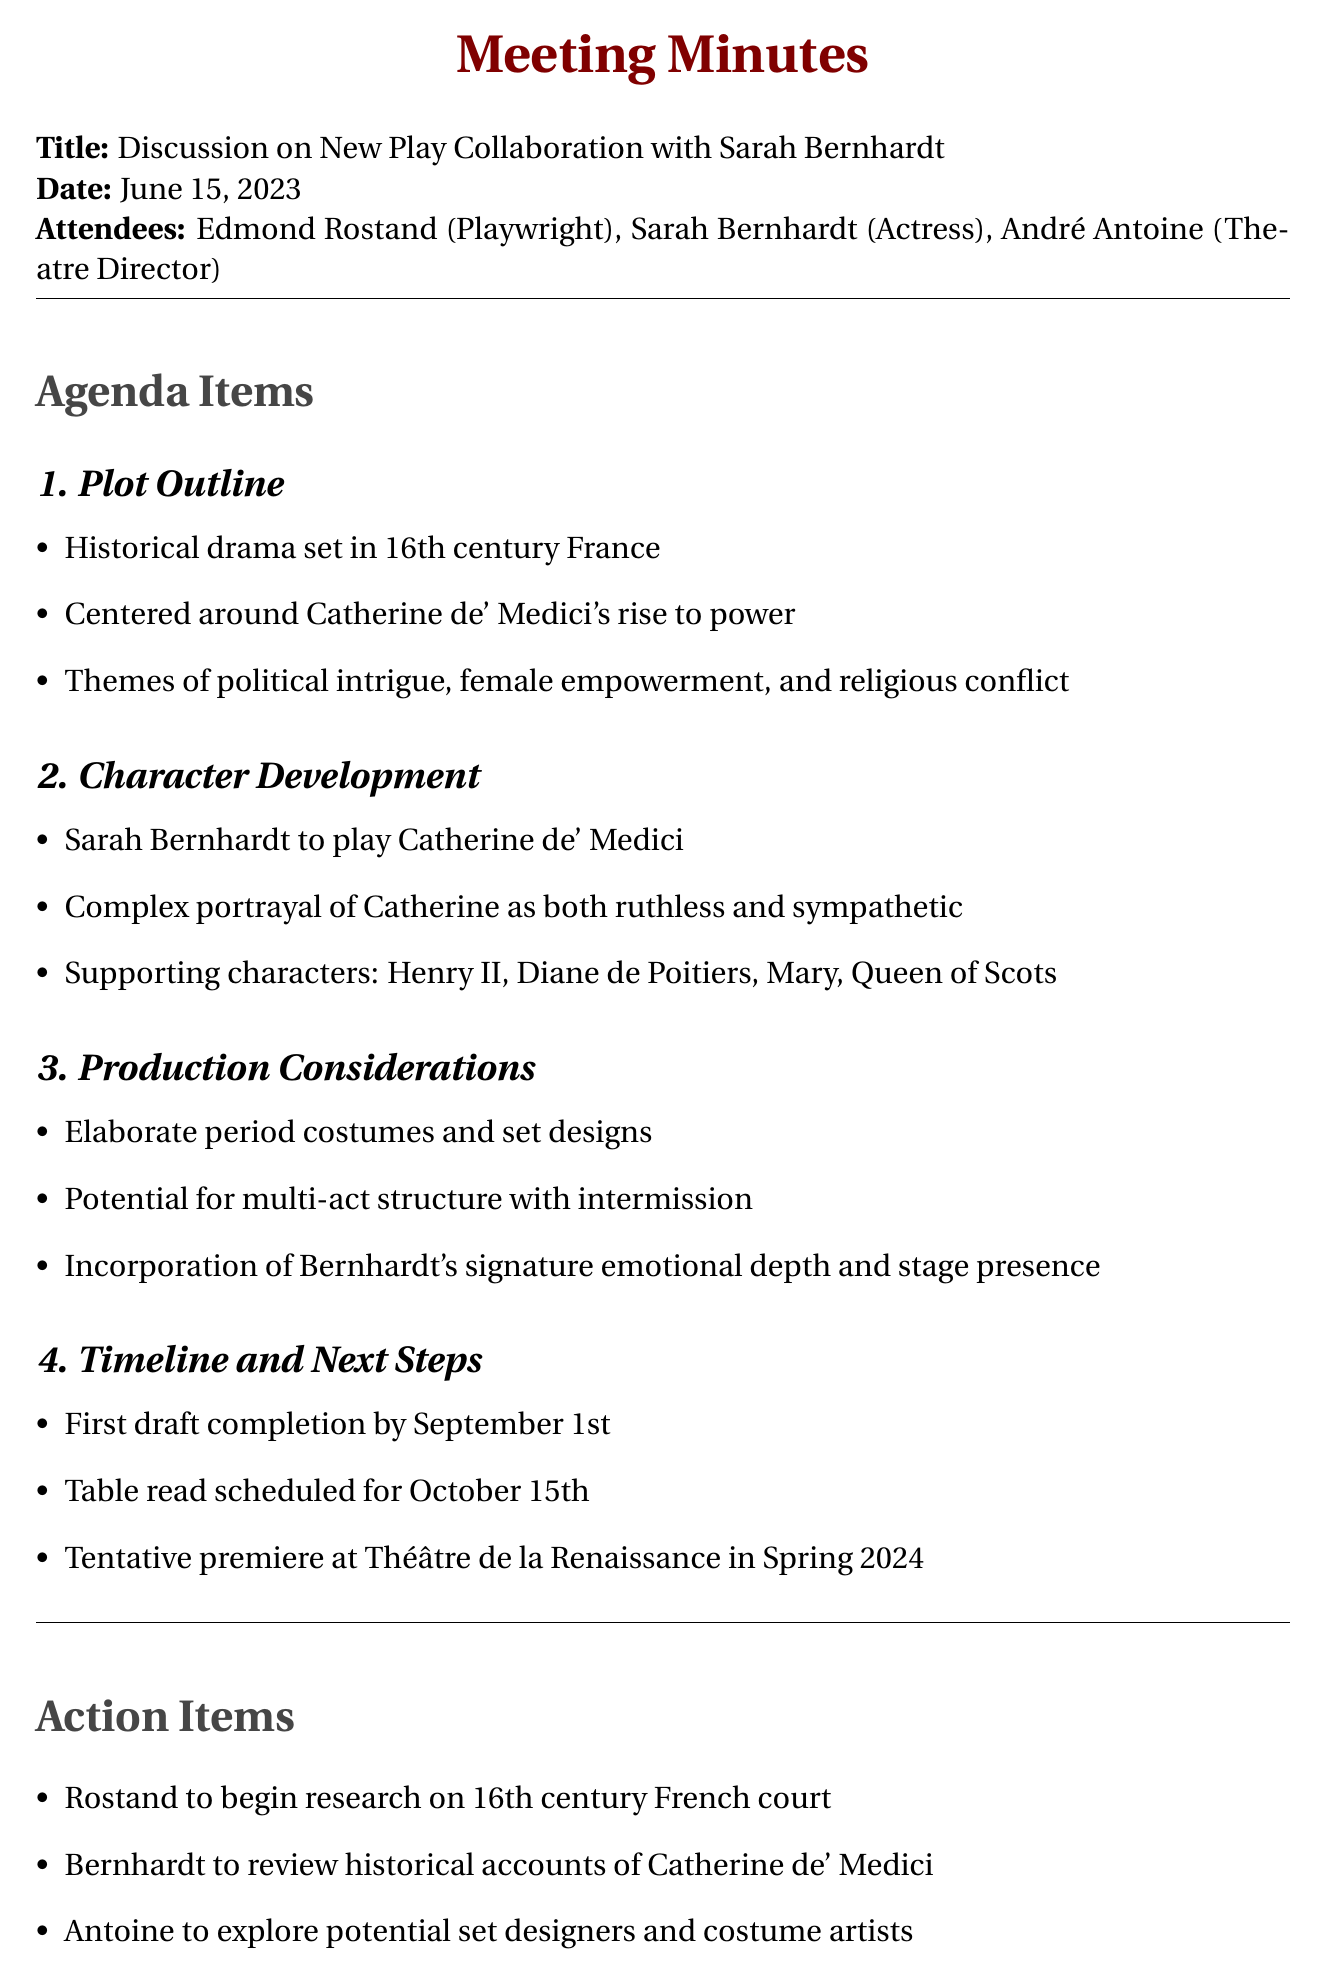What is the title of the meeting? The title of the meeting is explicitly stated in the document as "Discussion on New Play Collaboration with Sarah Bernhardt."
Answer: Discussion on New Play Collaboration with Sarah Bernhardt Who is the actress involved in the collaboration? The document mentions that Sarah Bernhardt is the actress attending the meeting.
Answer: Sarah Bernhardt What is the main theme of the play? The document outlines that the play's themes include political intrigue, female empowerment, and religious conflict.
Answer: Political intrigue, female empowerment, and religious conflict What is the completion date for the first draft? The document specifies that the first draft is to be completed by September 1st.
Answer: September 1st What character will Sarah Bernhardt portray? According to the meeting minutes, Sarah Bernhardt is set to play the role of Catherine de' Medici.
Answer: Catherine de' Medici What is a supporting character mentioned in the document? The document lists supporting characters, including Henry II, Diane de Poitiers, and Mary, Queen of Scots.
Answer: Henry II What is an action item assigned to Rostand? The document states that an action item for Rostand is to begin research on the 16th century French court.
Answer: Begin research on 16th century French court When is the table read scheduled? The document notes that the table read is scheduled for October 15th.
Answer: October 15th What type of play is being discussed? The document describes the play as a historical drama set in 16th century France.
Answer: Historical drama 